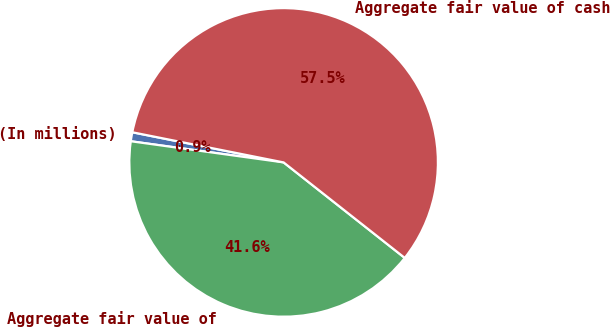Convert chart to OTSL. <chart><loc_0><loc_0><loc_500><loc_500><pie_chart><fcel>(In millions)<fcel>Aggregate fair value of<fcel>Aggregate fair value of cash<nl><fcel>0.94%<fcel>41.57%<fcel>57.5%<nl></chart> 